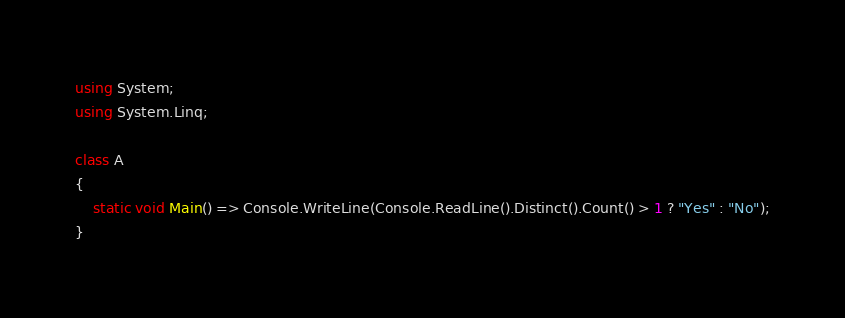Convert code to text. <code><loc_0><loc_0><loc_500><loc_500><_C#_>using System;
using System.Linq;

class A
{
	static void Main() => Console.WriteLine(Console.ReadLine().Distinct().Count() > 1 ? "Yes" : "No");
}
</code> 